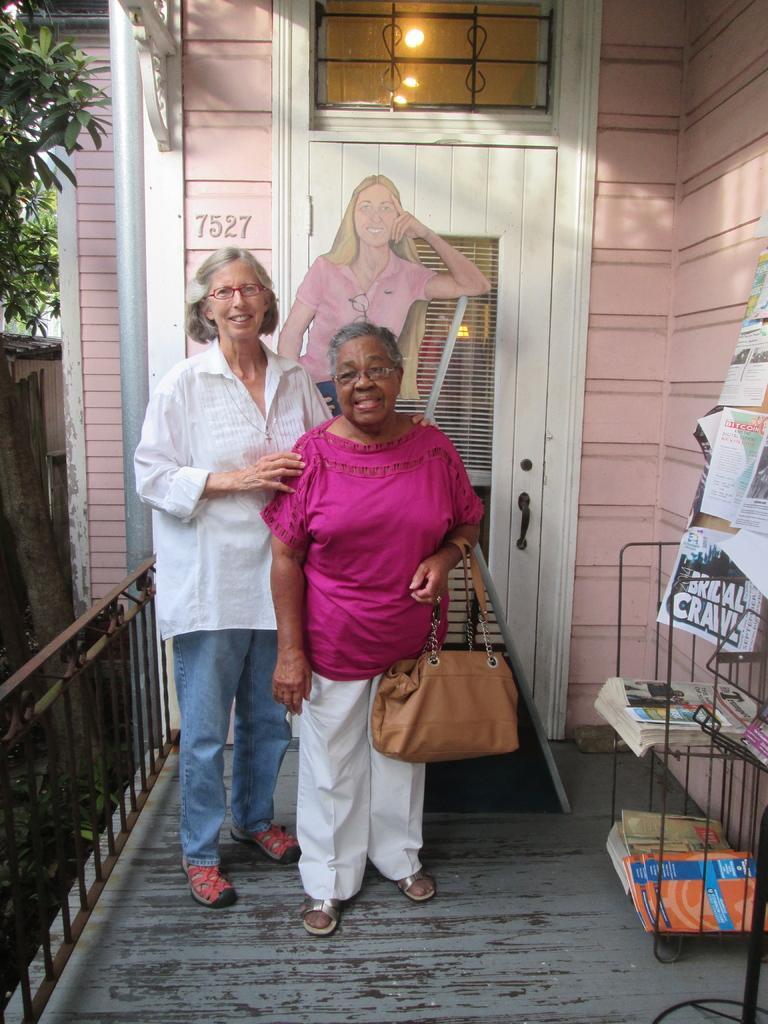How would you summarize this image in a sentence or two? Two women are posing to camera standing in front of a door. Of them one is holding a bag with her hand. 